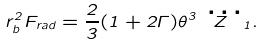Convert formula to latex. <formula><loc_0><loc_0><loc_500><loc_500>r _ { b } ^ { 2 } F _ { r a d } = \frac { 2 } { 3 } ( 1 + 2 \Gamma ) \theta ^ { 3 } \dddot { Z } _ { 1 } .</formula> 